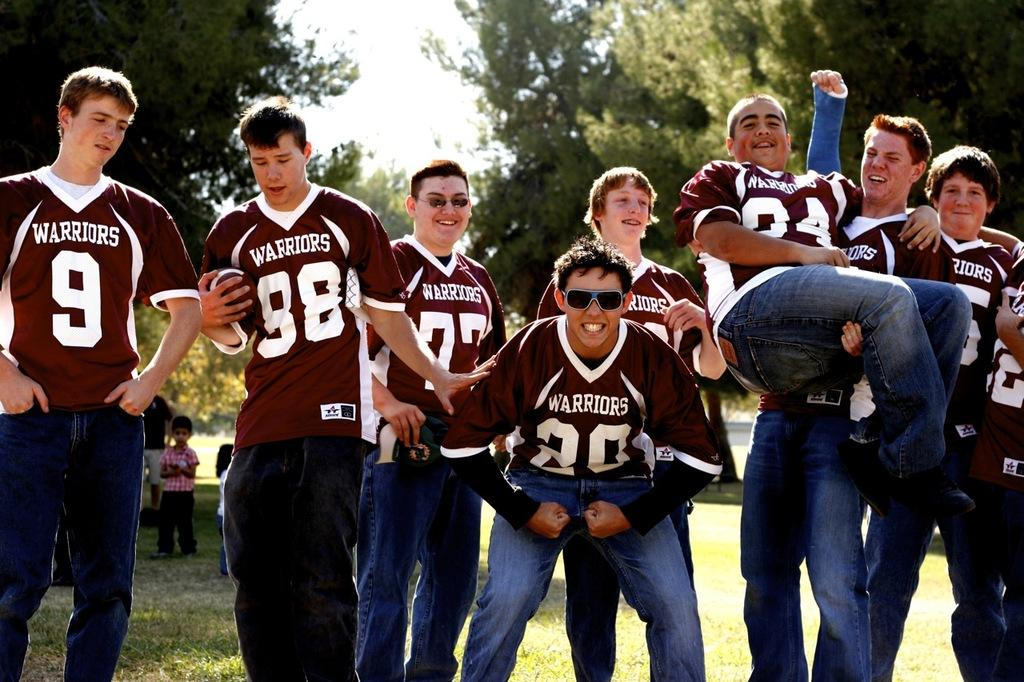Provide a one-sentence caption for the provided image. A footbal team named the Warriors posing for a picture. 